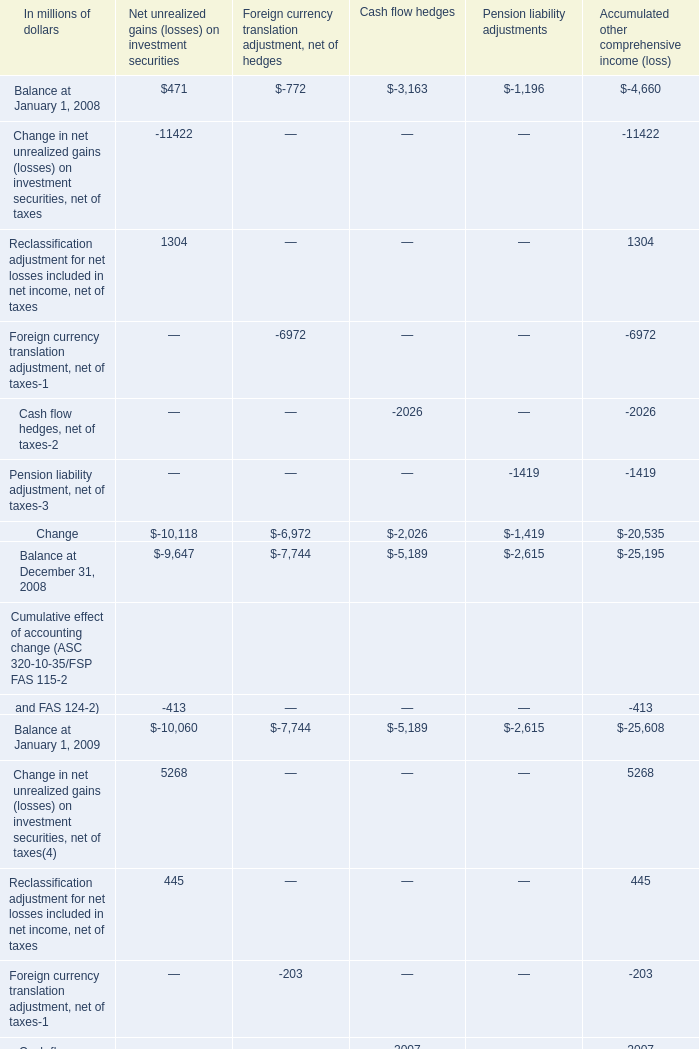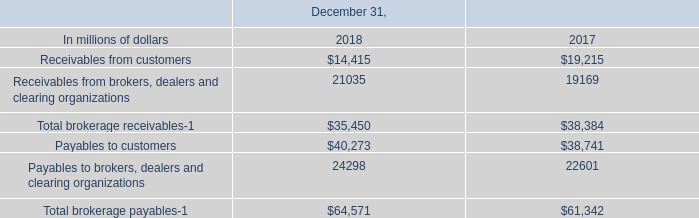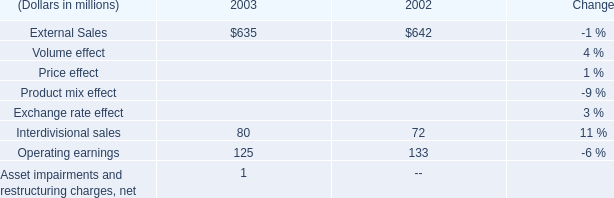What's the average of Payables to customers of December 31, 2018, and Change of Cash flow hedges ? 
Computations: ((40273.0 + 2026.0) / 2)
Answer: 21149.5. 